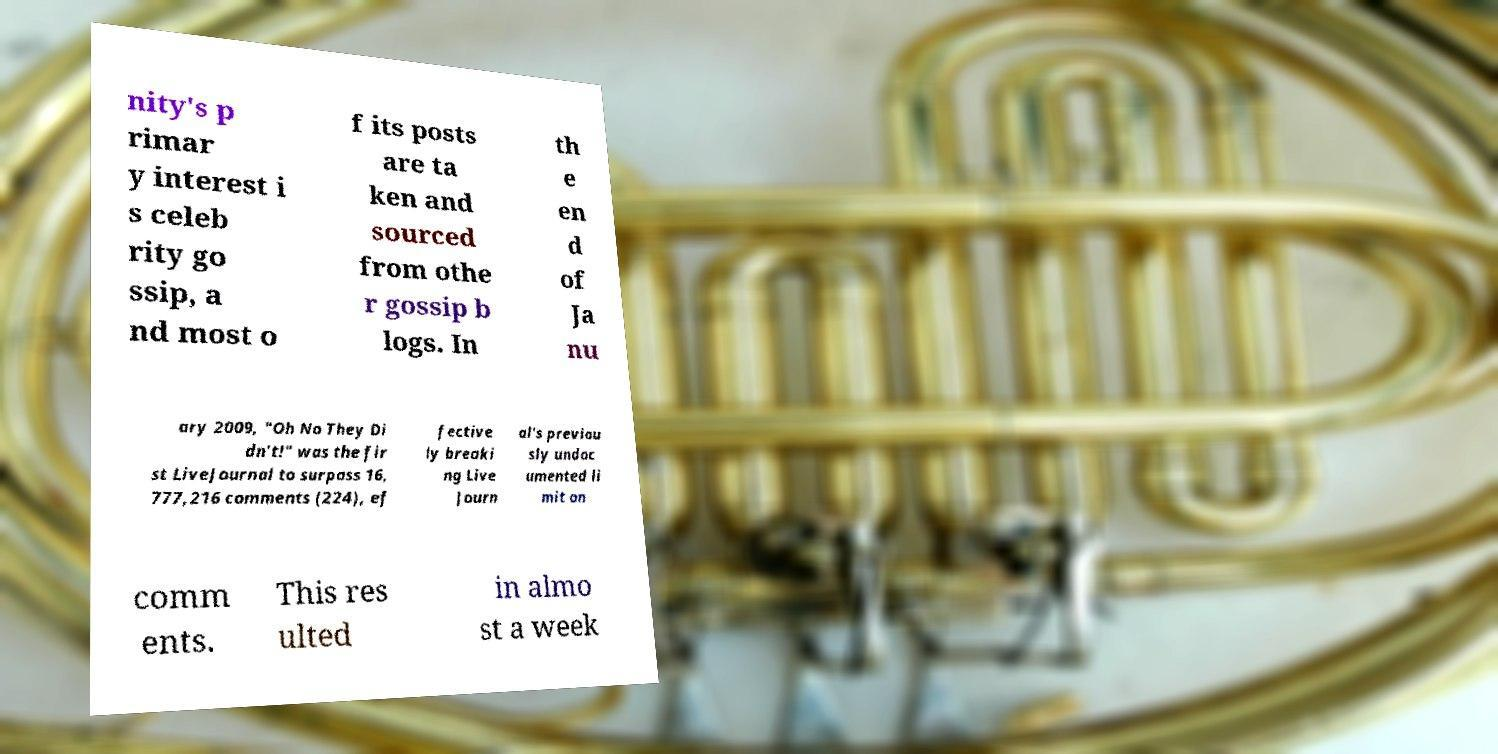Please identify and transcribe the text found in this image. nity's p rimar y interest i s celeb rity go ssip, a nd most o f its posts are ta ken and sourced from othe r gossip b logs. In th e en d of Ja nu ary 2009, "Oh No They Di dn't!" was the fir st LiveJournal to surpass 16, 777,216 comments (224), ef fective ly breaki ng Live Journ al's previou sly undoc umented li mit on comm ents. This res ulted in almo st a week 